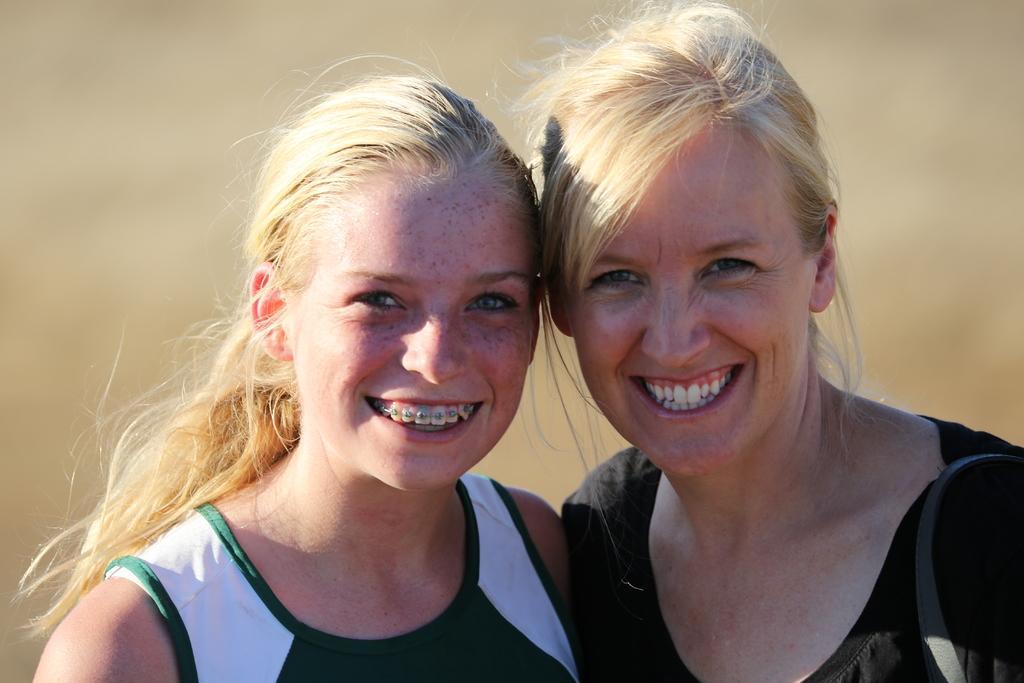How many people are in the image? There are two ladies in the image. What can be observed about the background in the image? The background of the image is blurred. What type of thread is being used by the ladies in the image? There is no thread present in the image, as it features two ladies and a blurred background. How many toes can be seen on the ladies in the image? The number of toes cannot be determined from the image, as it only shows the ladies from the waist up. 